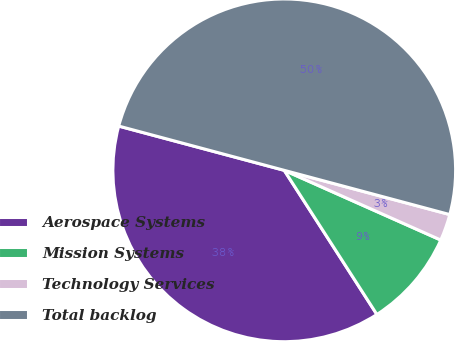<chart> <loc_0><loc_0><loc_500><loc_500><pie_chart><fcel>Aerospace Systems<fcel>Mission Systems<fcel>Technology Services<fcel>Total backlog<nl><fcel>38.25%<fcel>9.24%<fcel>2.51%<fcel>50.0%<nl></chart> 